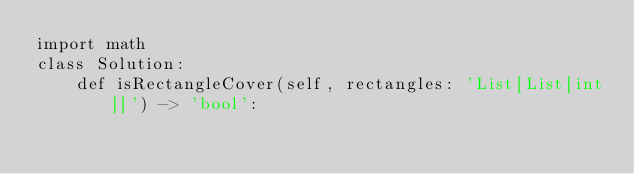<code> <loc_0><loc_0><loc_500><loc_500><_Python_>import math
class Solution:
    def isRectangleCover(self, rectangles: 'List[List[int]]') -> 'bool':</code> 